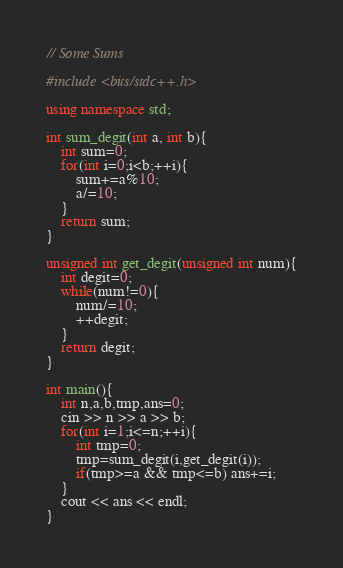<code> <loc_0><loc_0><loc_500><loc_500><_C++_>// Some Sums

#include <bits/stdc++.h>

using namespace std;

int sum_degit(int a, int b){
    int sum=0;
    for(int i=0;i<b;++i){
        sum+=a%10;
        a/=10;
    }
    return sum;
}

unsigned int get_degit(unsigned int num){
    int degit=0;
    while(num!=0){
        num/=10;
        ++degit;
    }
    return degit;
}

int main(){
    int n,a,b,tmp,ans=0;
    cin >> n >> a >> b;
    for(int i=1;i<=n;++i){
        int tmp=0;
        tmp=sum_degit(i,get_degit(i));
        if(tmp>=a && tmp<=b) ans+=i;
    }
    cout << ans << endl;
}
</code> 